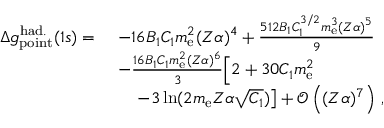Convert formula to latex. <formula><loc_0><loc_0><loc_500><loc_500>\begin{array} { r l } { \Delta { g } _ { p o i n t } ^ { h a d . } ( 1 s ) = \ } & { - 1 6 B _ { 1 } C _ { 1 } m _ { e } ^ { 2 } ( Z \alpha ) ^ { 4 } + \frac { 5 1 2 B _ { 1 } C _ { 1 } ^ { 3 / 2 } m _ { e } ^ { 3 } ( Z \alpha ) ^ { 5 } } { 9 } } \\ & { - \frac { 1 6 B _ { 1 } C _ { 1 } m _ { e } ^ { 2 } ( Z \alpha ) ^ { 6 } } { 3 } \Big [ 2 + 3 0 C _ { 1 } m _ { e } ^ { 2 } } \\ & { \quad - 3 \ln ( 2 m _ { e } Z \alpha \sqrt { C _ { 1 } } ) \right ] + \mathcal { O } \left ( ( Z \alpha ) ^ { 7 } \right ) \, , } \end{array}</formula> 